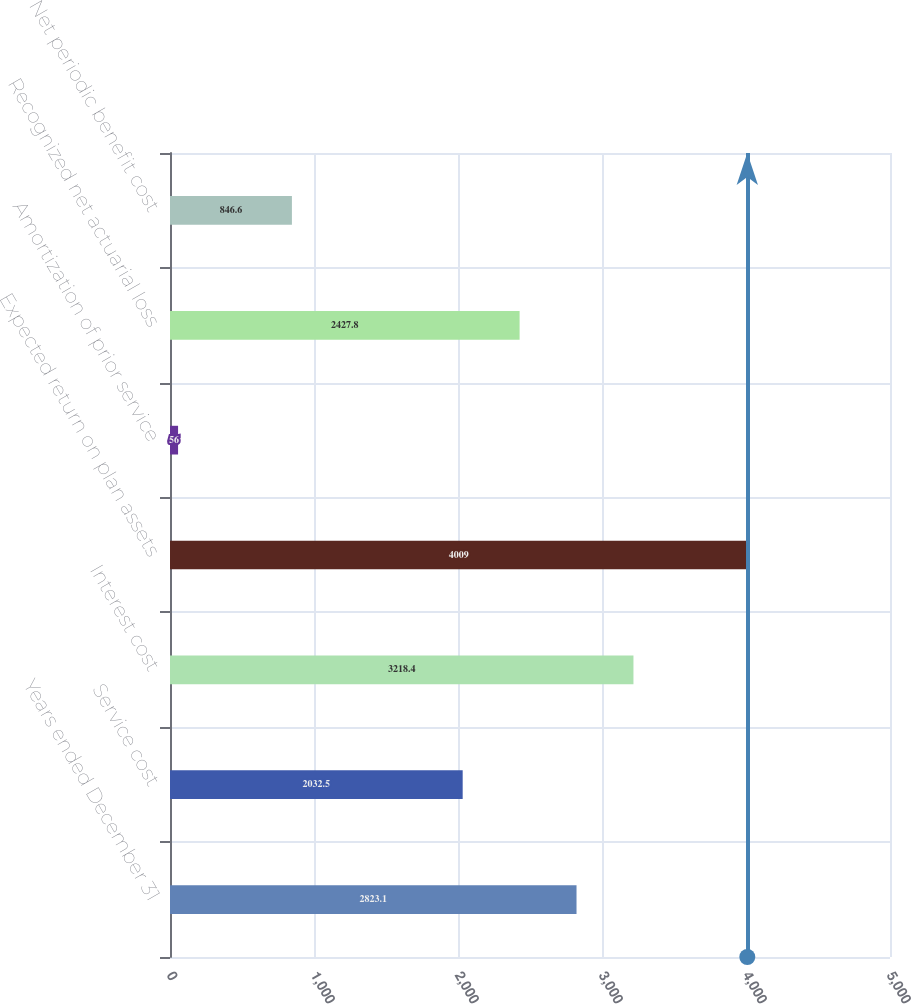Convert chart to OTSL. <chart><loc_0><loc_0><loc_500><loc_500><bar_chart><fcel>Years ended December 31<fcel>Service cost<fcel>Interest cost<fcel>Expected return on plan assets<fcel>Amortization of prior service<fcel>Recognized net actuarial loss<fcel>Net periodic benefit cost<nl><fcel>2823.1<fcel>2032.5<fcel>3218.4<fcel>4009<fcel>56<fcel>2427.8<fcel>846.6<nl></chart> 